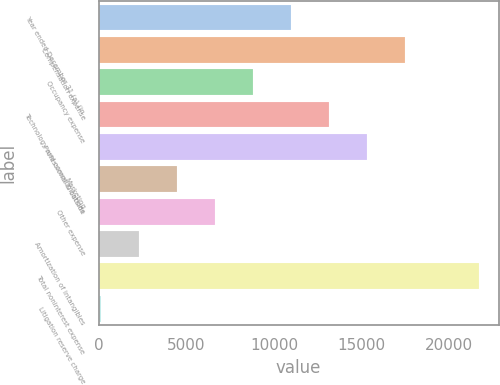Convert chart to OTSL. <chart><loc_0><loc_0><loc_500><loc_500><bar_chart><fcel>Year ended December 31 (a) (in<fcel>Compensation expense<fcel>Occupancy expense<fcel>Technology and communications<fcel>Professional & outside<fcel>Marketing<fcel>Other expense<fcel>Amortization of intangibles<fcel>Total noninterest expense<fcel>Litigation reserve charge<nl><fcel>10958<fcel>17472.8<fcel>8786.4<fcel>13129.6<fcel>15301.2<fcel>4443.2<fcel>6614.8<fcel>2271.6<fcel>21716<fcel>100<nl></chart> 